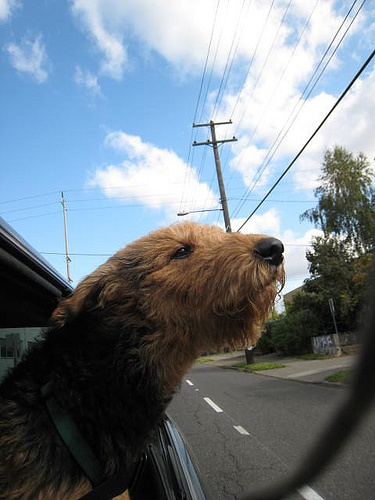Describe the objects in this image and their specific colors. I can see dog in lightgray, black, maroon, and gray tones and car in lightgray, black, gray, and darkgray tones in this image. 